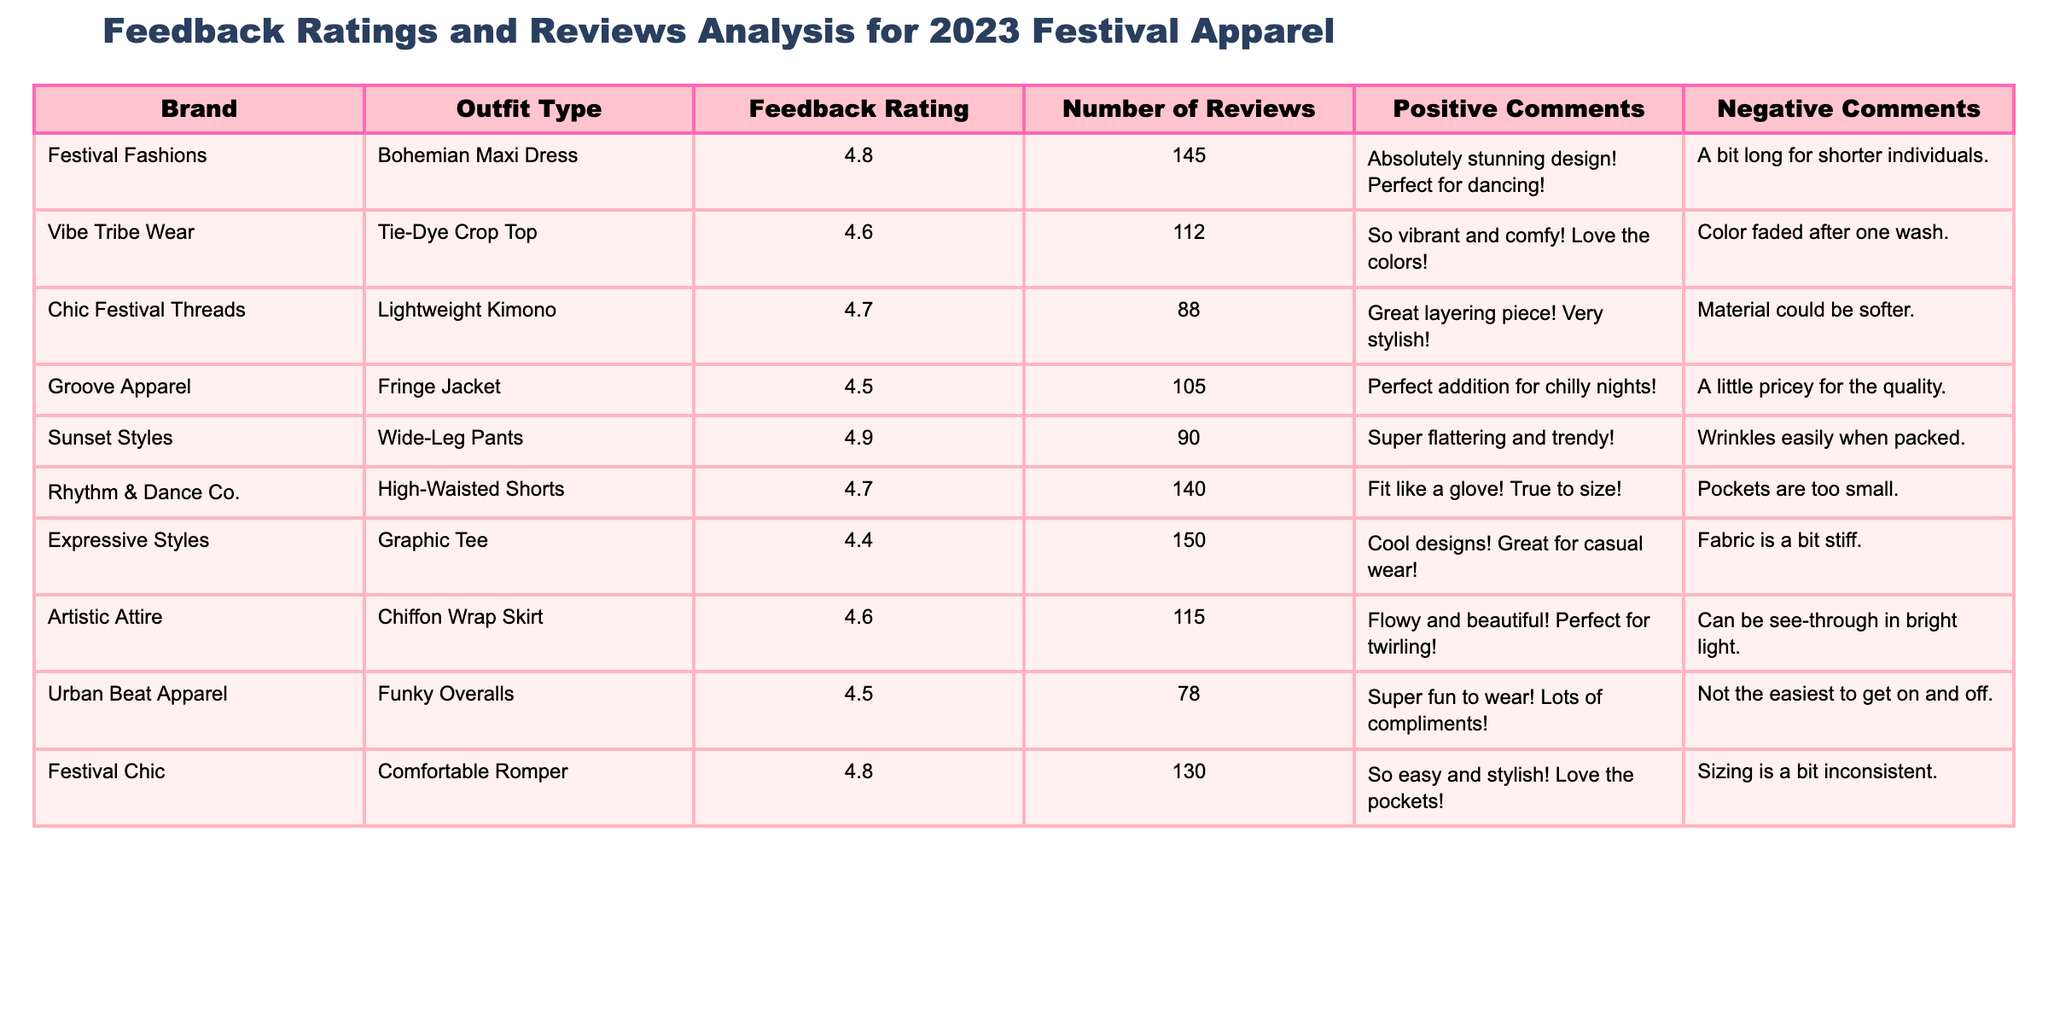What is the highest feedback rating among the outfits? The highest feedback rating in the table is 4.9, which corresponds to the "Wide-Leg Pants" from "Sunset Styles."
Answer: 4.9 Which outfit has the least number of reviews? The outfit with the least number of reviews is the "Funky Overalls" from "Urban Beat Apparel," with only 78 reviews.
Answer: 78 Is the "Fringe Jacket" rated higher than the "Tie-Dye Crop Top"? The "Fringe Jacket" has a rating of 4.5 while the "Tie-Dye Crop Top" has a rating of 4.6. Since 4.5 is less than 4.6, the statement is false.
Answer: No What is the average feedback rating of all the outfits? To find the average, sum all the feedback ratings: (4.8 + 4.6 + 4.7 + 4.5 + 4.9 + 4.7 + 4.4 + 4.6 + 4.5 + 4.8) = 46.6. There are 10 outfits, so the average rating is 46.6/10 = 4.66.
Answer: 4.66 How many outfits have a feedback rating of 4.7 or higher? The outfits with 4.7 or higher are "Bohemian Maxi Dress," "Lightweight Kimono," "Wide-Leg Pants," "High-Waisted Shorts," "Comfortable Romper," and "Chiffon Wrap Skirt," totaling 6 outfits.
Answer: 6 What percentage of reviews for "Graphic Tee" are positive comments? The feedback rating of the "Graphic Tee" is 4.4 with 150 reviews. Positive comments are not quantified in the table. It is unclear how many are positive from the given data, thus we cannot calculate a percentage.
Answer: Not determinable Which outfit type has the highest number of positive comments? Based on the comments, "Festival Chic" has "So easy and stylish! Love the pockets!" which implies positivity, but since we lack exact counts for the comments, we rely on the reviews. Therefore, we cannot determine a definitive count from the table data.
Answer: Not determinable Are there any outfits with comments on inconsistency in sizing? Yes, the "Comfortable Romper" mentions that "Sizing is a bit inconsistent" in the negative comments.
Answer: Yes What’s the difference in feedback rating between the "Chiffon Wrap Skirt" and the "Fringe Jacket"? The "Chiffon Wrap Skirt" has a rating of 4.6, and the "Fringe Jacket" has a rating of 4.5. The difference is 4.6 - 4.5 = 0.1.
Answer: 0.1 